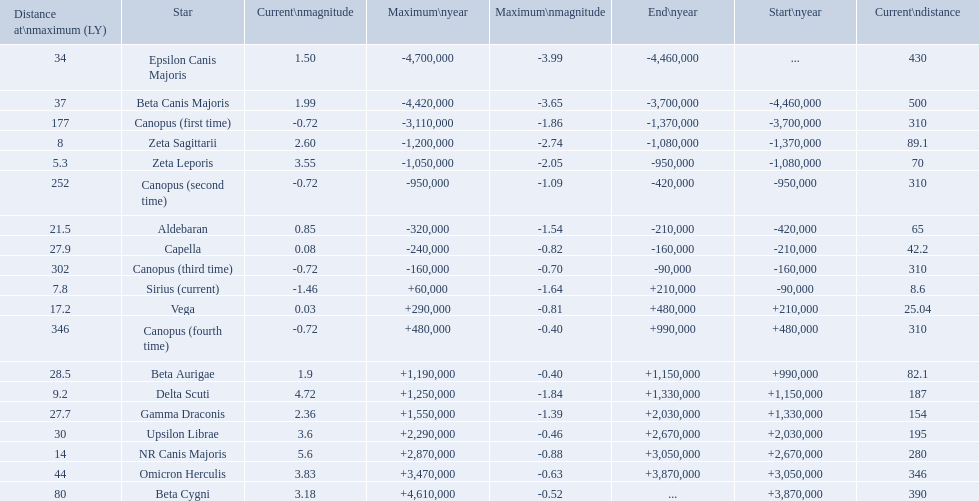What are all the stars? Epsilon Canis Majoris, Beta Canis Majoris, Canopus (first time), Zeta Sagittarii, Zeta Leporis, Canopus (second time), Aldebaran, Capella, Canopus (third time), Sirius (current), Vega, Canopus (fourth time), Beta Aurigae, Delta Scuti, Gamma Draconis, Upsilon Librae, NR Canis Majoris, Omicron Herculis, Beta Cygni. Of those, which star has a maximum distance of 80? Beta Cygni. 